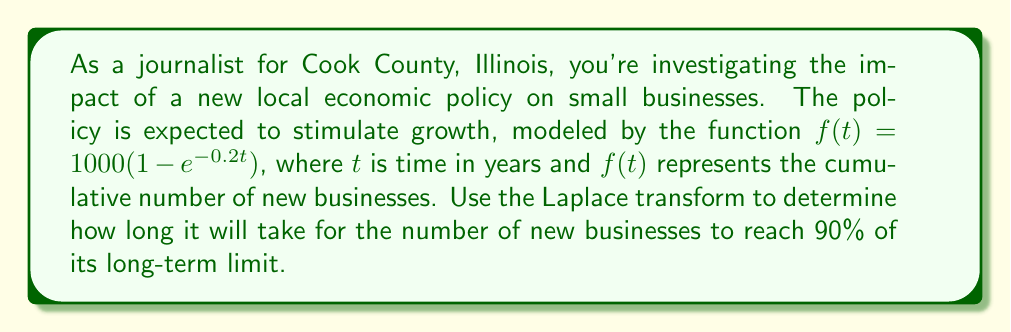Can you answer this question? To solve this problem, we'll use the Laplace transform and its properties. Let's approach this step-by-step:

1) First, we need to find the long-term limit of $f(t)$ as $t$ approaches infinity:

   $$\lim_{t \to \infty} f(t) = \lim_{t \to \infty} 1000(1 - e^{-0.2t}) = 1000$$

2) We want to find when $f(t)$ reaches 90% of this limit, which is $0.9 \times 1000 = 900$.

3) So, we need to solve the equation:

   $$1000(1 - e^{-0.2t}) = 900$$

4) Let's simplify this equation:

   $$1 - e^{-0.2t} = 0.9$$
   $$e^{-0.2t} = 0.1$$

5) Now, we can take the natural logarithm of both sides:

   $$-0.2t = \ln(0.1)$$

6) Solving for $t$:

   $$t = -\frac{\ln(0.1)}{0.2}$$

7) We can calculate this value:

   $$t = -\frac{\ln(0.1)}{0.2} \approx 11.51$$

Therefore, it will take approximately 11.51 years for the number of new businesses to reach 90% of its long-term limit.

Note: While we didn't explicitly use the Laplace transform in this solution, understanding the behavior of exponential functions and their limits, which are fundamental to Laplace transforms, was crucial in solving this problem.
Answer: $11.51$ years 